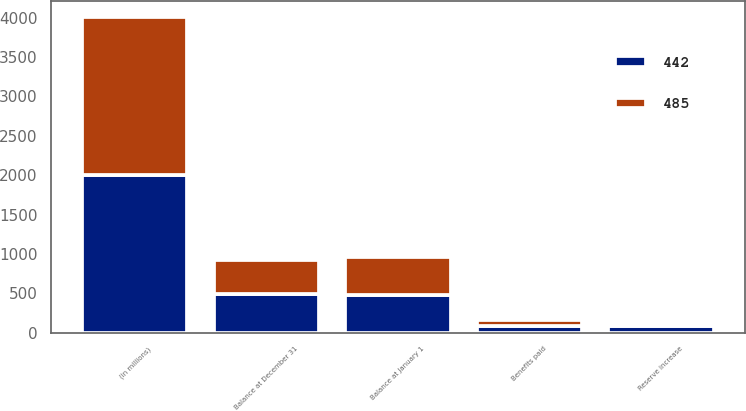Convert chart. <chart><loc_0><loc_0><loc_500><loc_500><stacked_bar_chart><ecel><fcel>(in millions)<fcel>Balance at January 1<fcel>Reserve increase<fcel>Benefits paid<fcel>Balance at December 31<nl><fcel>485<fcel>2005<fcel>485<fcel>33<fcel>76<fcel>442<nl><fcel>442<fcel>2004<fcel>479<fcel>86<fcel>80<fcel>485<nl></chart> 